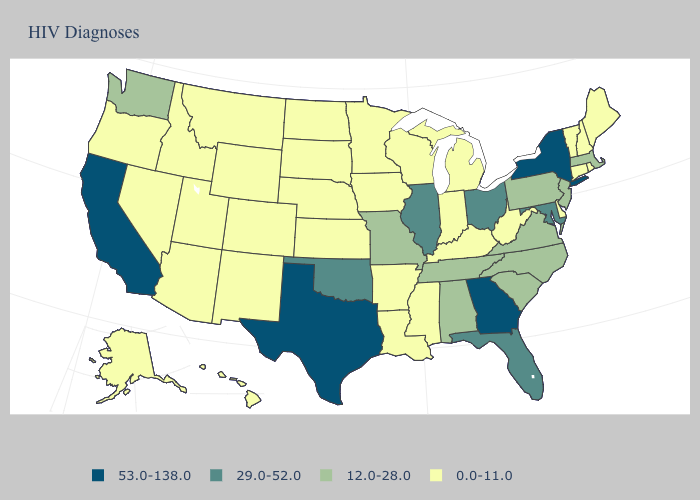What is the lowest value in the USA?
Keep it brief. 0.0-11.0. What is the value of Iowa?
Be succinct. 0.0-11.0. What is the value of Indiana?
Write a very short answer. 0.0-11.0. Does the map have missing data?
Keep it brief. No. What is the value of New Hampshire?
Quick response, please. 0.0-11.0. What is the value of Indiana?
Concise answer only. 0.0-11.0. What is the highest value in states that border Wyoming?
Give a very brief answer. 0.0-11.0. What is the value of Louisiana?
Give a very brief answer. 0.0-11.0. What is the highest value in the USA?
Be succinct. 53.0-138.0. Among the states that border Oregon , which have the lowest value?
Quick response, please. Idaho, Nevada. Does Connecticut have the lowest value in the Northeast?
Short answer required. Yes. Is the legend a continuous bar?
Write a very short answer. No. Which states have the lowest value in the USA?
Quick response, please. Alaska, Arizona, Arkansas, Colorado, Connecticut, Delaware, Hawaii, Idaho, Indiana, Iowa, Kansas, Kentucky, Louisiana, Maine, Michigan, Minnesota, Mississippi, Montana, Nebraska, Nevada, New Hampshire, New Mexico, North Dakota, Oregon, Rhode Island, South Dakota, Utah, Vermont, West Virginia, Wisconsin, Wyoming. Does Nebraska have the same value as Oregon?
Concise answer only. Yes. Name the states that have a value in the range 12.0-28.0?
Write a very short answer. Alabama, Massachusetts, Missouri, New Jersey, North Carolina, Pennsylvania, South Carolina, Tennessee, Virginia, Washington. 